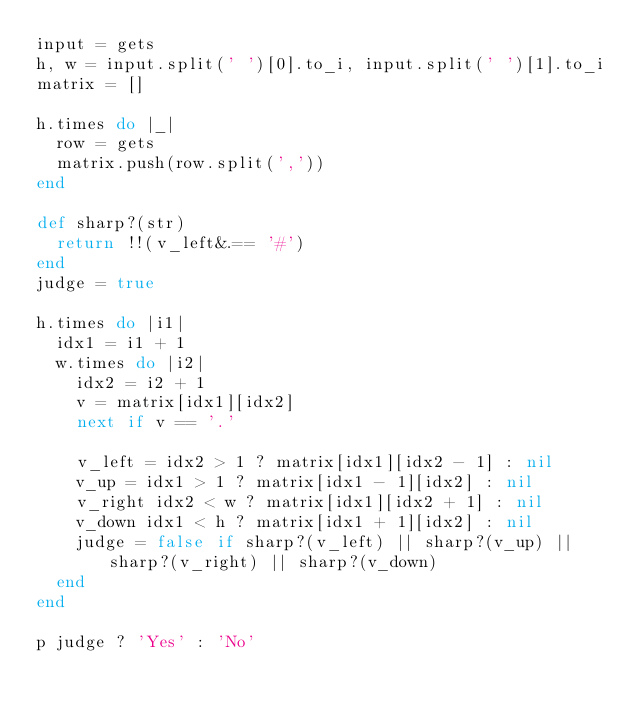Convert code to text. <code><loc_0><loc_0><loc_500><loc_500><_Ruby_>input = gets
h, w = input.split(' ')[0].to_i, input.split(' ')[1].to_i
matrix = []

h.times do |_|
  row = gets
  matrix.push(row.split(','))
end

def sharp?(str)
  return !!(v_left&.== '#')
end
judge = true

h.times do |i1|
  idx1 = i1 + 1
  w.times do |i2|
    idx2 = i2 + 1
    v = matrix[idx1][idx2]
    next if v == '.'

    v_left = idx2 > 1 ? matrix[idx1][idx2 - 1] : nil
    v_up = idx1 > 1 ? matrix[idx1 - 1][idx2] : nil
    v_right idx2 < w ? matrix[idx1][idx2 + 1] : nil
    v_down idx1 < h ? matrix[idx1 + 1][idx2] : nil
    judge = false if sharp?(v_left) || sharp?(v_up) || sharp?(v_right) || sharp?(v_down)
  end
end

p judge ? 'Yes' : 'No'</code> 